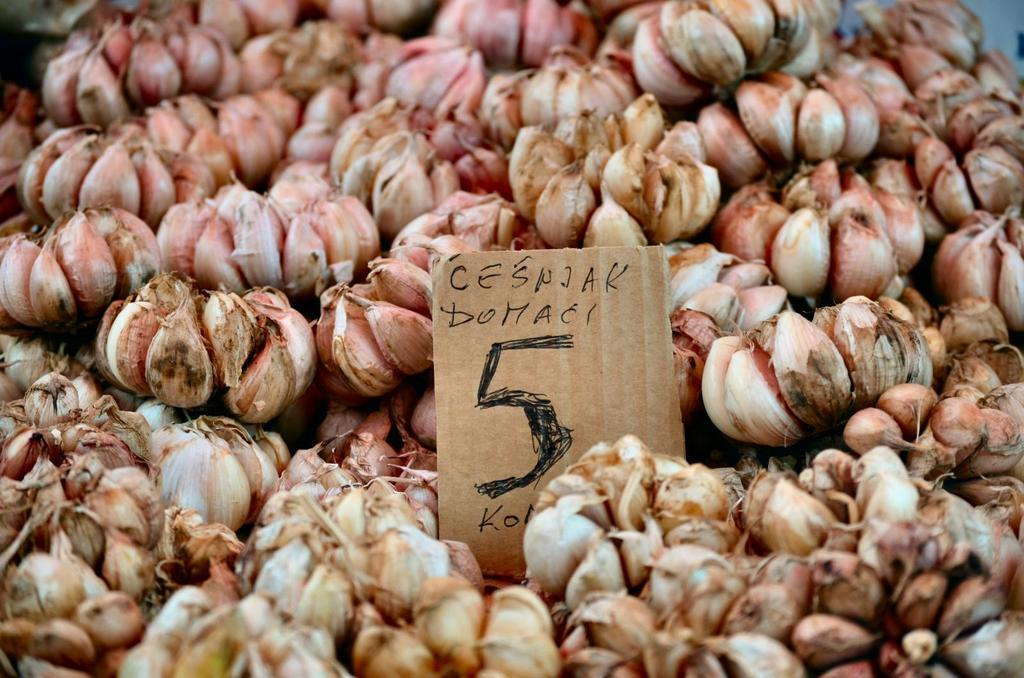What type of food is visible in the image? There is a group of garlic in the image. What else can be seen in the image besides the garlic? There is a card with text on it in the image. How many chairs are visible in the image? There are no chairs present in the image. What type of fruit can be seen be seen in the image? There is no fruit present in the image; it features a group of garlic and a card with text on it. 